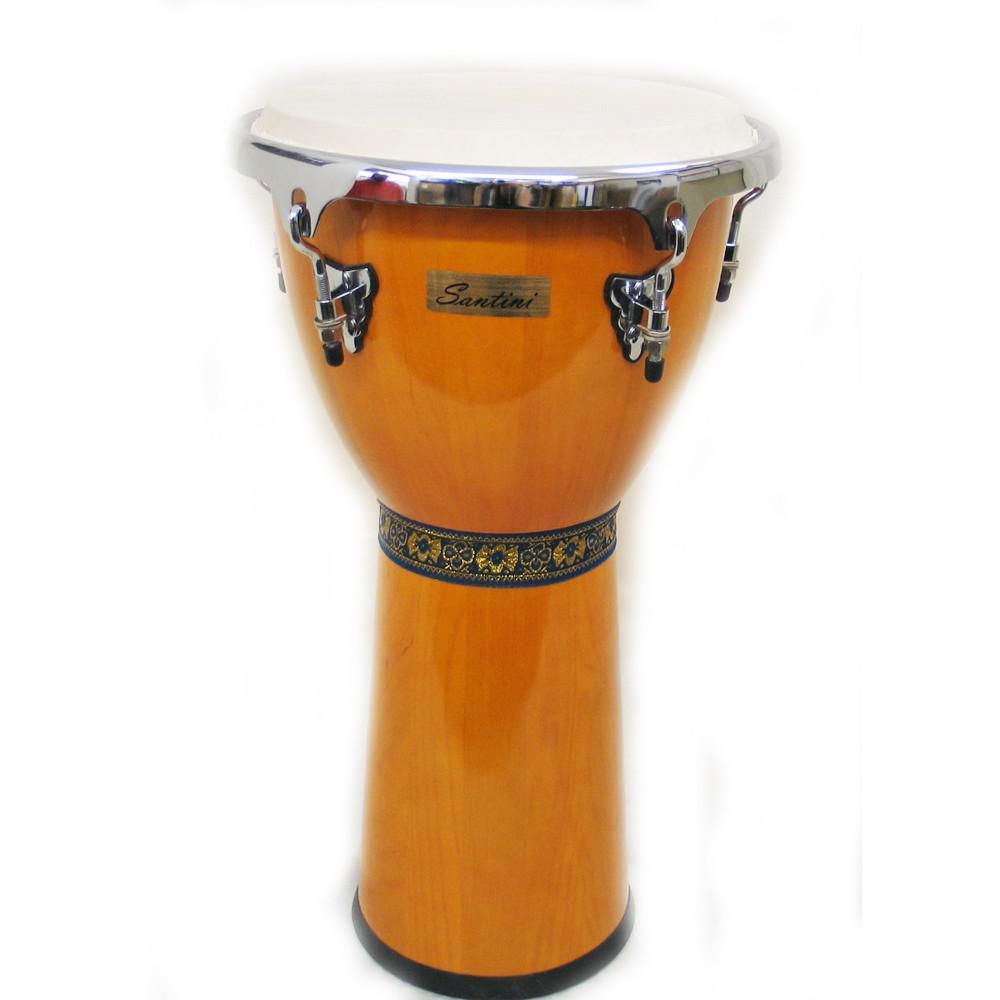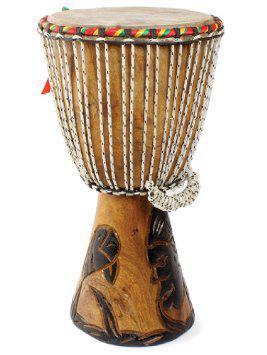The first image is the image on the left, the second image is the image on the right. Analyze the images presented: Is the assertion "There are exactly two bongo drums." valid? Answer yes or no. Yes. 